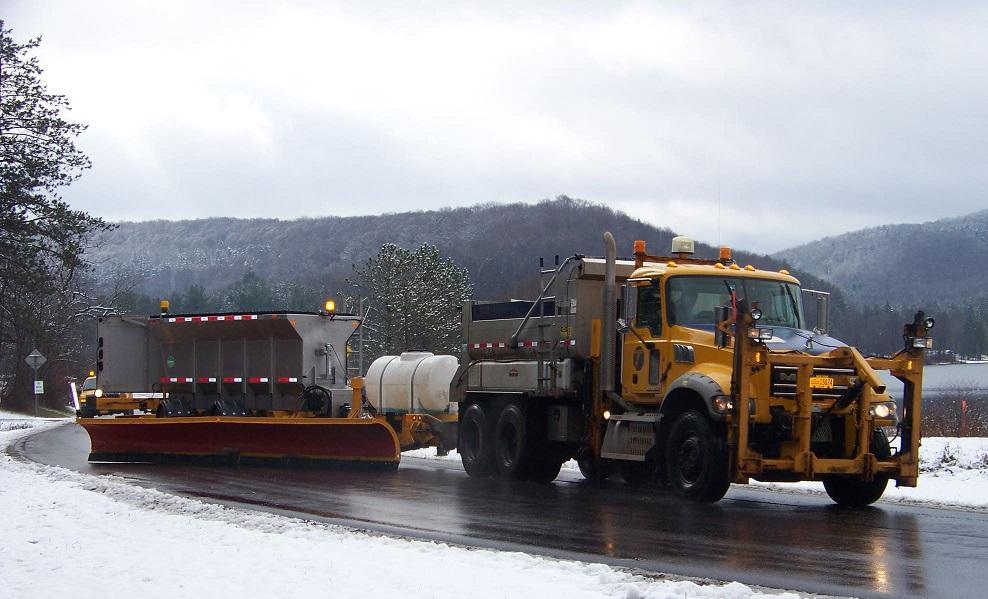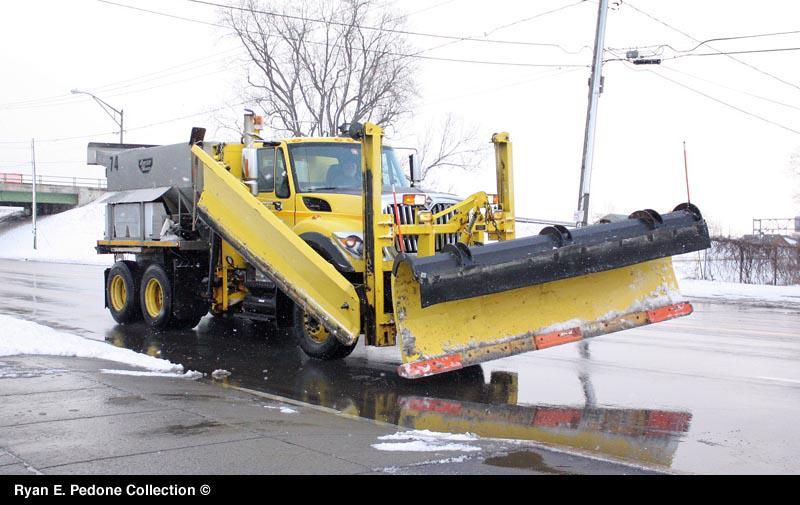The first image is the image on the left, the second image is the image on the right. For the images shown, is this caption "A bulldozers front panel is partially lifted off the ground." true? Answer yes or no. Yes. 